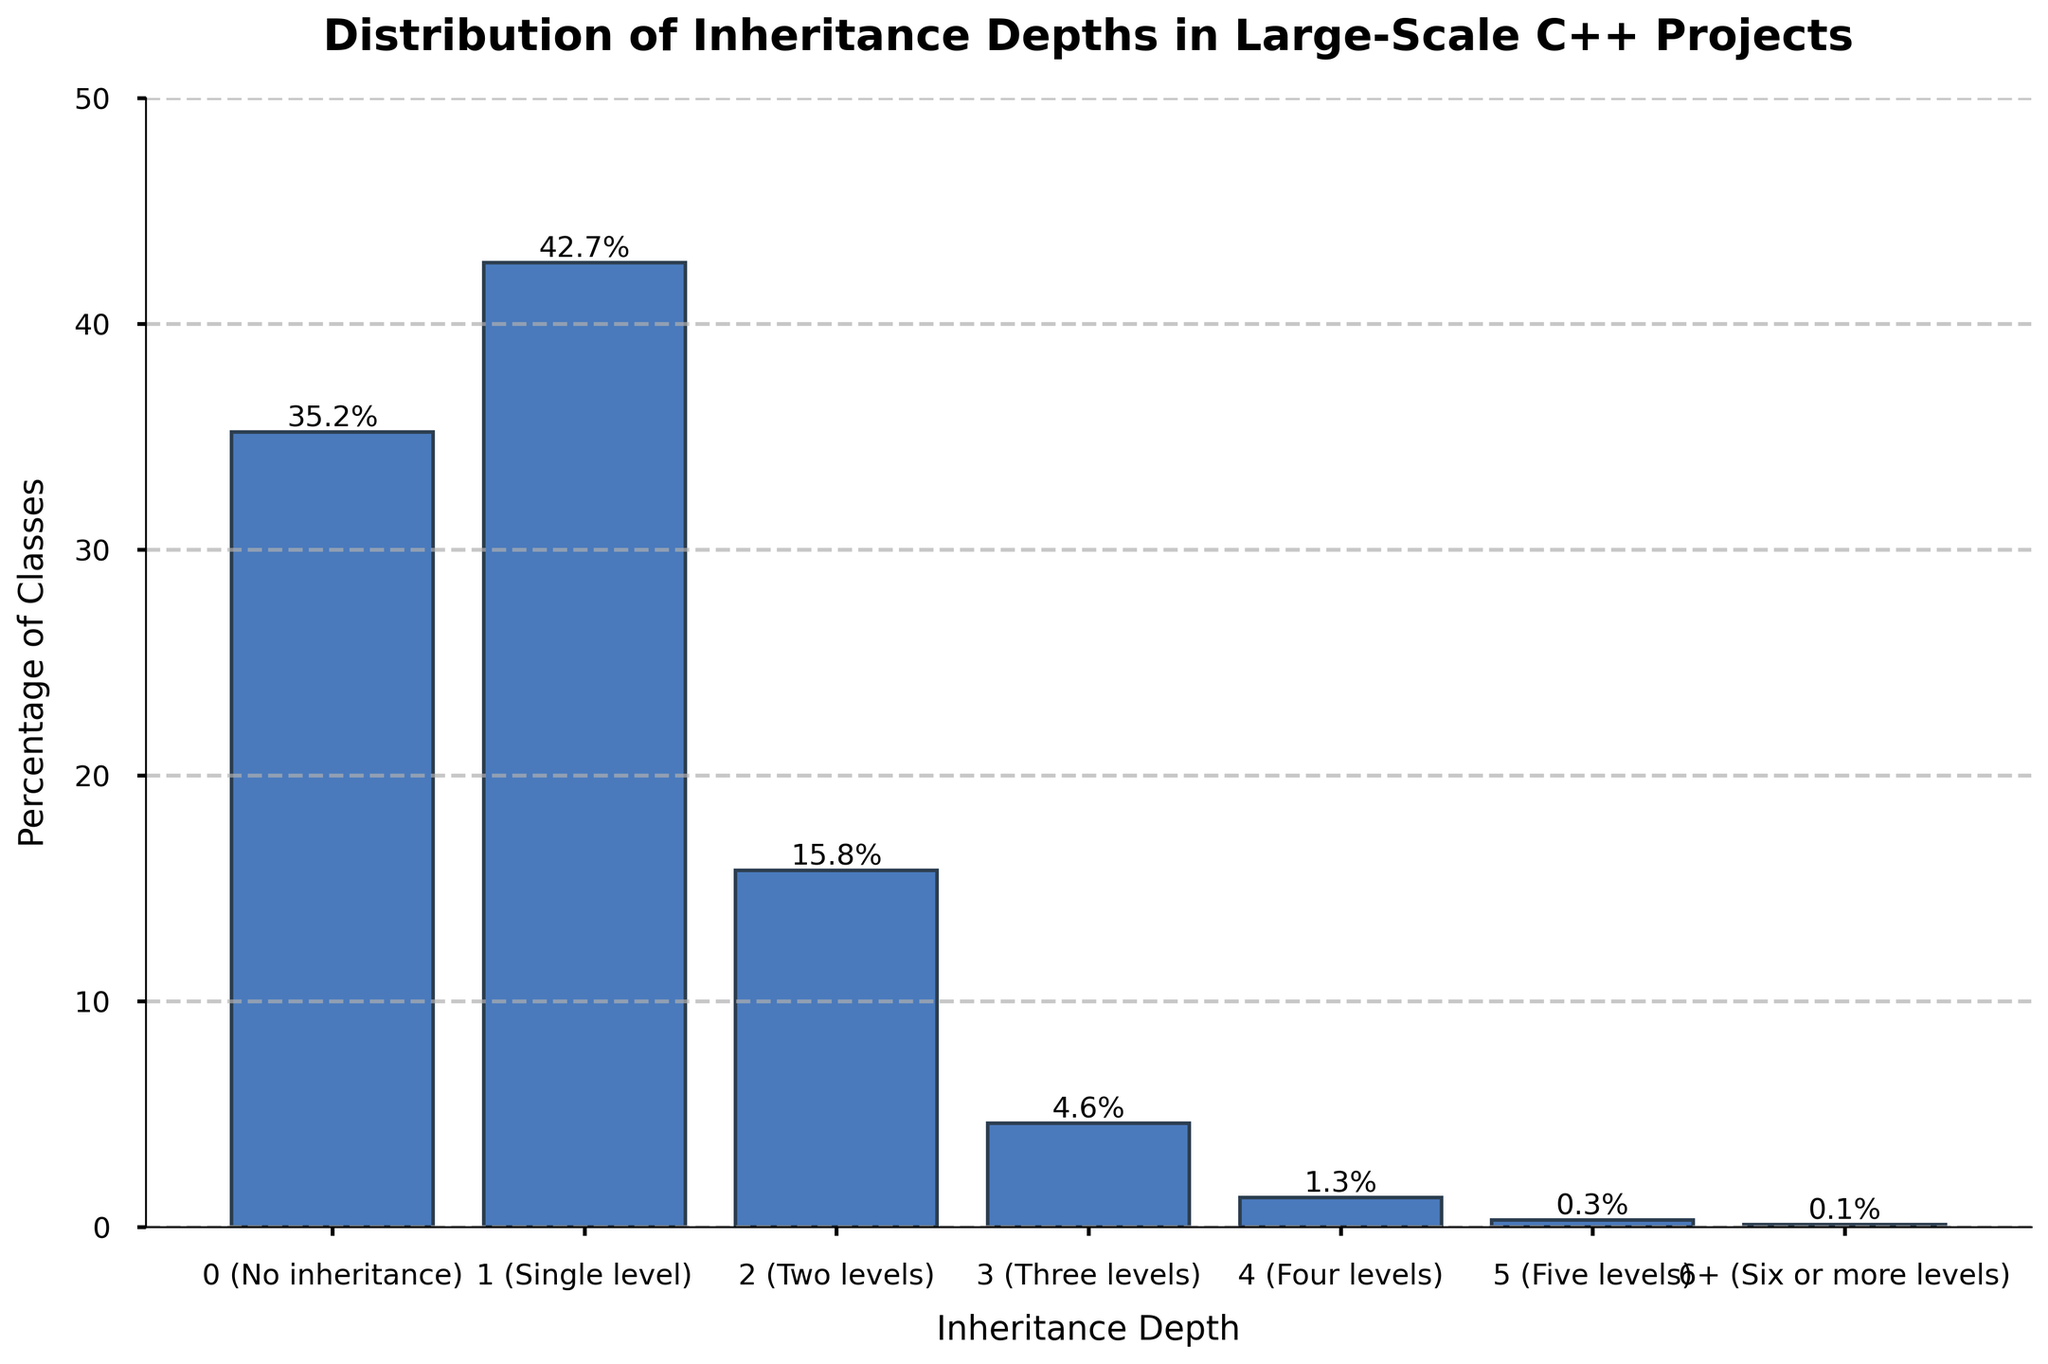What is the inheritance depth level with the highest percentage of classes? Observing the bar chart, the tallest bar represents the highest percentage. It corresponds to the inheritance depth of 1.
Answer: 1 Which inheritance depth accounts for less than 1% of the classes? By looking at the bars and their labels, we see that the bar for 6+ is the only one under 1%.
Answer: 6+ Compare the percentage of classes with no inheritance to those with one level of inheritance. Which is higher and by how much? The bar for no inheritance (0) has a height of 35.2%, while the bar for one level (1) has 42.7%. The difference is calculated as 42.7% - 35.2% = 7.5%.
Answer: 1 is higher by 7.5% What is the total percentage of classes with three or more levels of inheritance? Sum the percentages of classes with inheritance depths of 3, 4, 5, and 6+. These percentages are 4.6%, 1.3%, 0.3%, and 0.1%, respectively. The total is 4.6 + 1.3 + 0.3 + 0.1 = 6.3%.
Answer: 6.3% Do the majority of classes have an inheritance depth of two levels or less? Adding up the percentages for inheritance depths 0, 1, and 2, we get 35.2% + 42.7% + 15.8% = 93.7%. Since 93.7% > 50%, the majority do have an inheritance depth of two levels or less.
Answer: Yes How does the percentage of classes with no inheritance compare to the total percentage of classes with an inheritance depth of three levels or less? Sum the percentages for depths 0, 1, 2, and 3, which are 35.2%, 42.7%, 15.8%, and 4.6%, respectively. The total is 35.2 + 42.7 + 15.8 + 4.6 = 98.3%. The percentage with no inheritance is 35.2%, which is part of this total.
Answer: It's part of 98.3% What visual indicators show that more classes have lower inheritance depths? The bars representing lower inheritance depths (0, 1, 2) are the tallest, indicating higher percentages. The heights of the bars decrease significantly as the inheritance depth increases.
Answer: Taller bars at lower depths What is the combined percentage of classes with either no inheritance or a single inheritance level? Add the percentages for inheritance depths 0 and 1: 35.2% + 42.7% = 77.9%.
Answer: 77.9% What is the difference between the percentage of classes with a two-level inheritance depth and those with a three-level inheritance depth? The percentage for a two-level depth is 15.8%, and for three levels is 4.6%. The difference is 15.8% - 4.6% = 11.2%.
Answer: 11.2% Based on the chart, how rare is it for classes to have an inheritance depth of four levels or more? The percentages for depths 4, 5, and 6+ are 1.3%, 0.3%, and 0.1%, respectively, all of which are very low. Summing them gives 1.3 + 0.3 + 0.1 = 1.7%, showing it is quite rare.
Answer: Very rare (1.7%) 